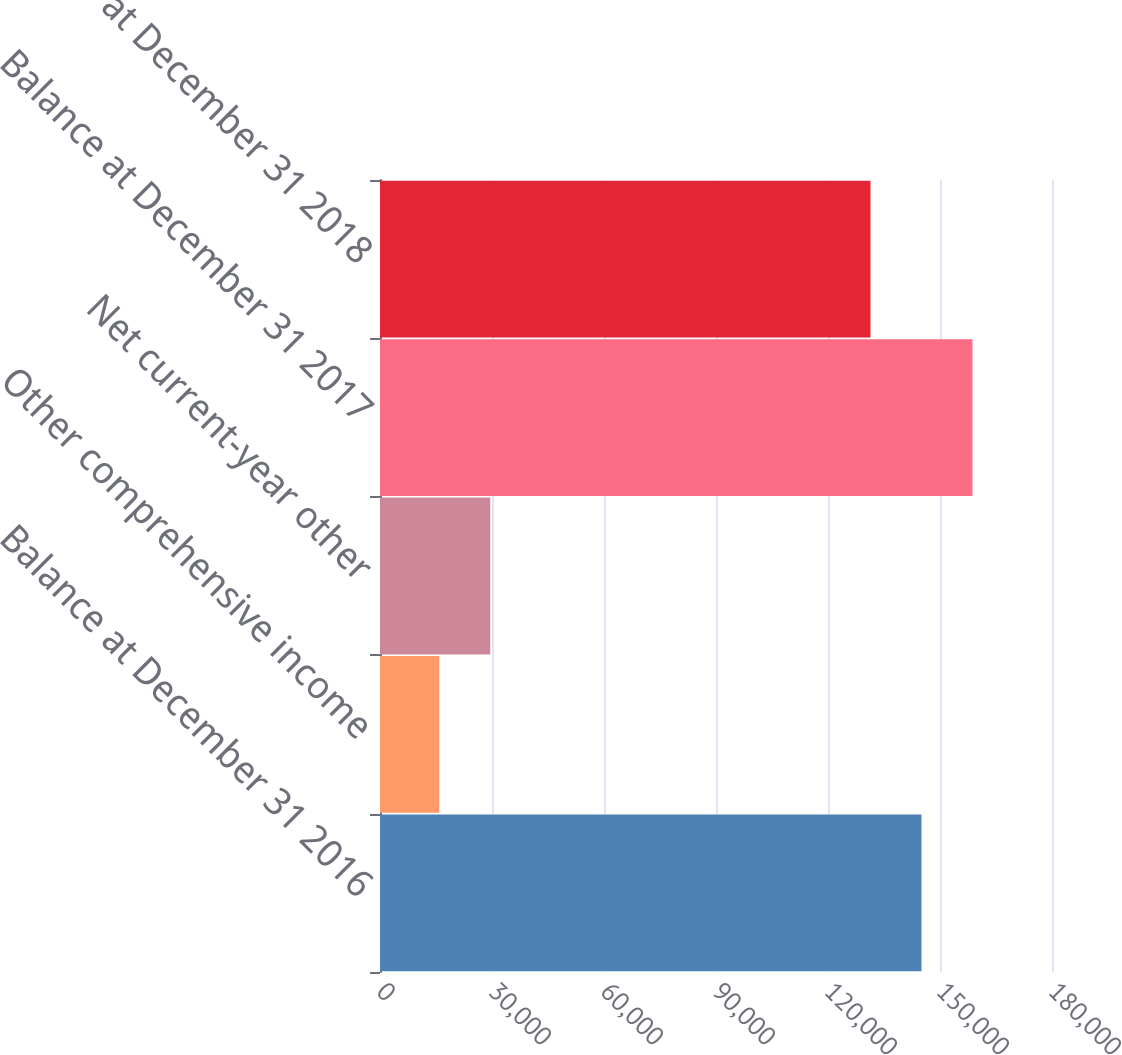Convert chart. <chart><loc_0><loc_0><loc_500><loc_500><bar_chart><fcel>Balance at December 31 2016<fcel>Other comprehensive income<fcel>Net current-year other<fcel>Balance at December 31 2017<fcel>Balance at December 31 2018<nl><fcel>145040<fcel>15871.6<fcel>29531.2<fcel>158699<fcel>131380<nl></chart> 